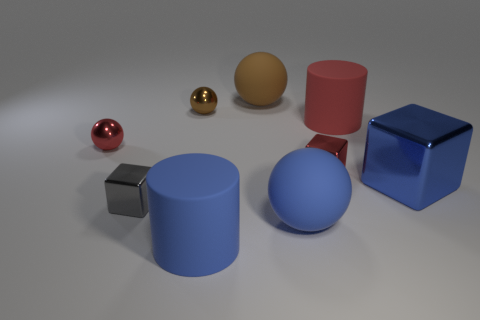What is the color of the big sphere that is in front of the large cylinder that is on the right side of the matte sphere in front of the blue metallic cube?
Give a very brief answer. Blue. Is the number of small red metal things that are on the left side of the big blue matte cylinder the same as the number of tiny yellow things?
Your response must be concise. No. Is there anything else that has the same material as the small brown object?
Offer a very short reply. Yes. There is a big metal object; is it the same color as the tiny metallic object in front of the blue block?
Ensure brevity in your answer.  No. Are there any small metal cubes that are in front of the tiny block that is to the left of the metal sphere that is behind the small red shiny sphere?
Provide a short and direct response. No. Are there fewer big spheres on the left side of the big blue metal thing than small gray shiny blocks?
Your answer should be compact. No. How many other objects are there of the same shape as the gray object?
Offer a very short reply. 2. What number of things are blue rubber spheres right of the red metal ball or red shiny objects to the left of the large brown object?
Your answer should be compact. 2. What size is the metallic thing that is both in front of the tiny red metallic cube and left of the big brown matte object?
Ensure brevity in your answer.  Small. There is a big matte thing that is on the right side of the small red cube; is it the same shape as the gray thing?
Provide a short and direct response. No. 